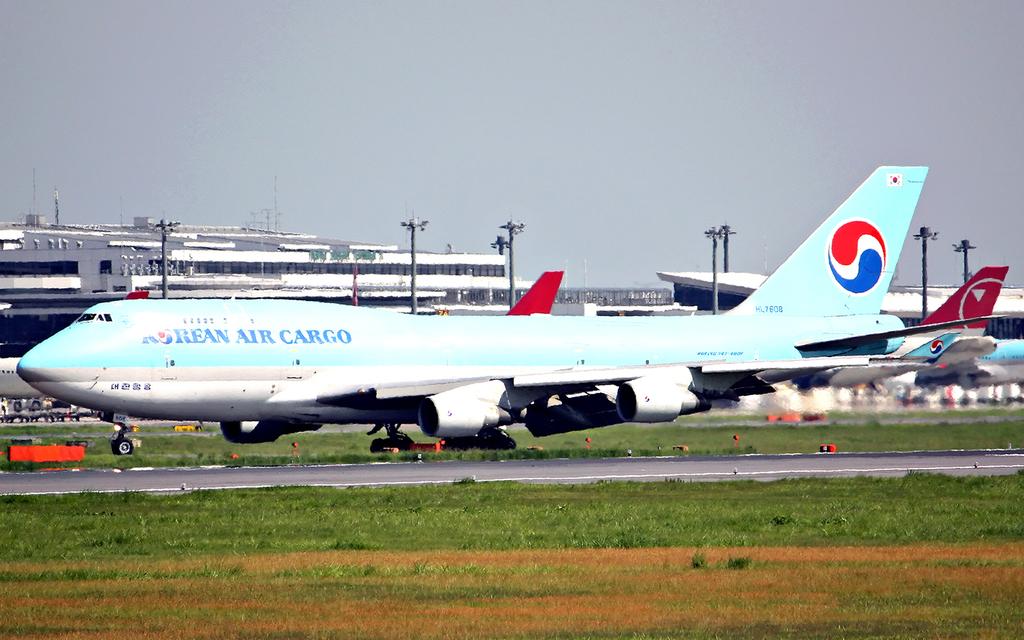Which airline is that plane from?
Offer a terse response. Korean air. 